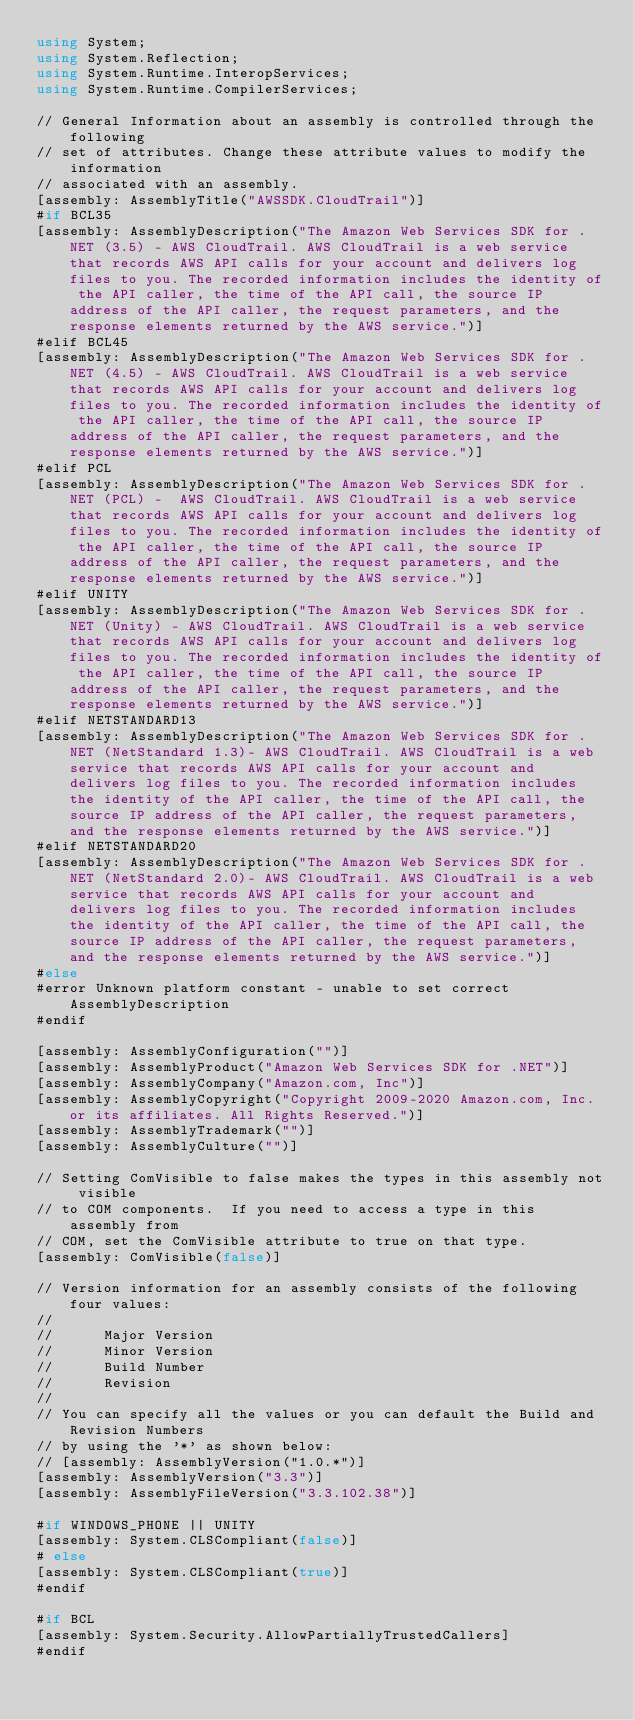Convert code to text. <code><loc_0><loc_0><loc_500><loc_500><_C#_>using System;
using System.Reflection;
using System.Runtime.InteropServices;
using System.Runtime.CompilerServices;

// General Information about an assembly is controlled through the following 
// set of attributes. Change these attribute values to modify the information
// associated with an assembly.
[assembly: AssemblyTitle("AWSSDK.CloudTrail")]
#if BCL35
[assembly: AssemblyDescription("The Amazon Web Services SDK for .NET (3.5) - AWS CloudTrail. AWS CloudTrail is a web service that records AWS API calls for your account and delivers log files to you. The recorded information includes the identity of the API caller, the time of the API call, the source IP address of the API caller, the request parameters, and the response elements returned by the AWS service.")]
#elif BCL45
[assembly: AssemblyDescription("The Amazon Web Services SDK for .NET (4.5) - AWS CloudTrail. AWS CloudTrail is a web service that records AWS API calls for your account and delivers log files to you. The recorded information includes the identity of the API caller, the time of the API call, the source IP address of the API caller, the request parameters, and the response elements returned by the AWS service.")]
#elif PCL
[assembly: AssemblyDescription("The Amazon Web Services SDK for .NET (PCL) -  AWS CloudTrail. AWS CloudTrail is a web service that records AWS API calls for your account and delivers log files to you. The recorded information includes the identity of the API caller, the time of the API call, the source IP address of the API caller, the request parameters, and the response elements returned by the AWS service.")]
#elif UNITY
[assembly: AssemblyDescription("The Amazon Web Services SDK for .NET (Unity) - AWS CloudTrail. AWS CloudTrail is a web service that records AWS API calls for your account and delivers log files to you. The recorded information includes the identity of the API caller, the time of the API call, the source IP address of the API caller, the request parameters, and the response elements returned by the AWS service.")]
#elif NETSTANDARD13
[assembly: AssemblyDescription("The Amazon Web Services SDK for .NET (NetStandard 1.3)- AWS CloudTrail. AWS CloudTrail is a web service that records AWS API calls for your account and delivers log files to you. The recorded information includes the identity of the API caller, the time of the API call, the source IP address of the API caller, the request parameters, and the response elements returned by the AWS service.")]
#elif NETSTANDARD20
[assembly: AssemblyDescription("The Amazon Web Services SDK for .NET (NetStandard 2.0)- AWS CloudTrail. AWS CloudTrail is a web service that records AWS API calls for your account and delivers log files to you. The recorded information includes the identity of the API caller, the time of the API call, the source IP address of the API caller, the request parameters, and the response elements returned by the AWS service.")]
#else
#error Unknown platform constant - unable to set correct AssemblyDescription
#endif

[assembly: AssemblyConfiguration("")]
[assembly: AssemblyProduct("Amazon Web Services SDK for .NET")]
[assembly: AssemblyCompany("Amazon.com, Inc")]
[assembly: AssemblyCopyright("Copyright 2009-2020 Amazon.com, Inc. or its affiliates. All Rights Reserved.")]
[assembly: AssemblyTrademark("")]
[assembly: AssemblyCulture("")]

// Setting ComVisible to false makes the types in this assembly not visible 
// to COM components.  If you need to access a type in this assembly from 
// COM, set the ComVisible attribute to true on that type.
[assembly: ComVisible(false)]

// Version information for an assembly consists of the following four values:
//
//      Major Version
//      Minor Version 
//      Build Number
//      Revision
//
// You can specify all the values or you can default the Build and Revision Numbers 
// by using the '*' as shown below:
// [assembly: AssemblyVersion("1.0.*")]
[assembly: AssemblyVersion("3.3")]
[assembly: AssemblyFileVersion("3.3.102.38")]

#if WINDOWS_PHONE || UNITY
[assembly: System.CLSCompliant(false)]
# else
[assembly: System.CLSCompliant(true)]
#endif

#if BCL
[assembly: System.Security.AllowPartiallyTrustedCallers]
#endif</code> 